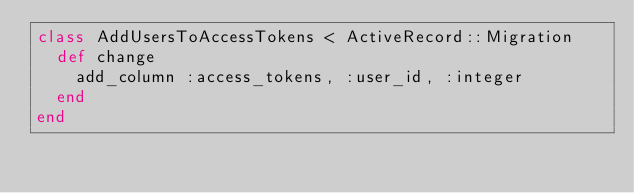Convert code to text. <code><loc_0><loc_0><loc_500><loc_500><_Ruby_>class AddUsersToAccessTokens < ActiveRecord::Migration
  def change
    add_column :access_tokens, :user_id, :integer
  end
end
</code> 